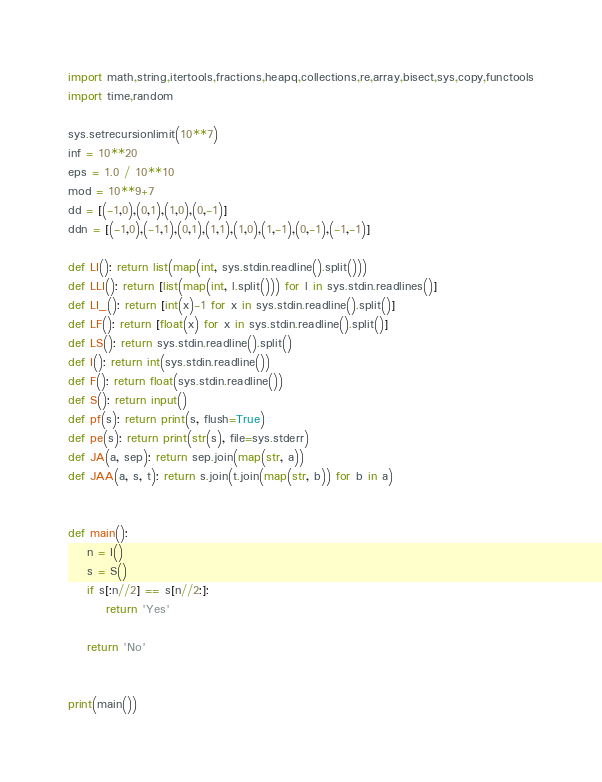Convert code to text. <code><loc_0><loc_0><loc_500><loc_500><_Python_>import math,string,itertools,fractions,heapq,collections,re,array,bisect,sys,copy,functools
import time,random

sys.setrecursionlimit(10**7)
inf = 10**20
eps = 1.0 / 10**10
mod = 10**9+7
dd = [(-1,0),(0,1),(1,0),(0,-1)]
ddn = [(-1,0),(-1,1),(0,1),(1,1),(1,0),(1,-1),(0,-1),(-1,-1)]

def LI(): return list(map(int, sys.stdin.readline().split()))
def LLI(): return [list(map(int, l.split())) for l in sys.stdin.readlines()]
def LI_(): return [int(x)-1 for x in sys.stdin.readline().split()]
def LF(): return [float(x) for x in sys.stdin.readline().split()]
def LS(): return sys.stdin.readline().split()
def I(): return int(sys.stdin.readline())
def F(): return float(sys.stdin.readline())
def S(): return input()
def pf(s): return print(s, flush=True)
def pe(s): return print(str(s), file=sys.stderr)
def JA(a, sep): return sep.join(map(str, a))
def JAA(a, s, t): return s.join(t.join(map(str, b)) for b in a)


def main():
    n = I()
    s = S()
    if s[:n//2] == s[n//2:]:
        return 'Yes'

    return 'No'


print(main())


</code> 